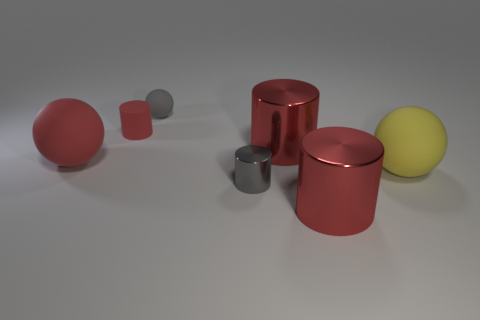There is a tiny matte object that is the same color as the tiny metallic cylinder; what shape is it?
Offer a terse response. Sphere. What is the material of the large cylinder that is behind the thing that is right of the big red metallic cylinder in front of the small shiny object?
Offer a very short reply. Metal. The gray sphere that is the same material as the yellow object is what size?
Provide a succinct answer. Small. Are there any big cylinders of the same color as the tiny matte sphere?
Your answer should be very brief. No. Is the size of the gray cylinder the same as the gray thing behind the big yellow sphere?
Offer a terse response. Yes. There is a large red shiny cylinder behind the big sphere that is right of the tiny metal cylinder; how many yellow rubber things are behind it?
Keep it short and to the point. 0. What size is the other thing that is the same color as the tiny metallic thing?
Offer a very short reply. Small. Are there any tiny matte cylinders in front of the small shiny object?
Your answer should be very brief. No. What shape is the tiny red object?
Give a very brief answer. Cylinder. What shape is the tiny matte thing that is on the left side of the tiny matte object that is right of the tiny red matte object behind the large yellow matte thing?
Your response must be concise. Cylinder. 